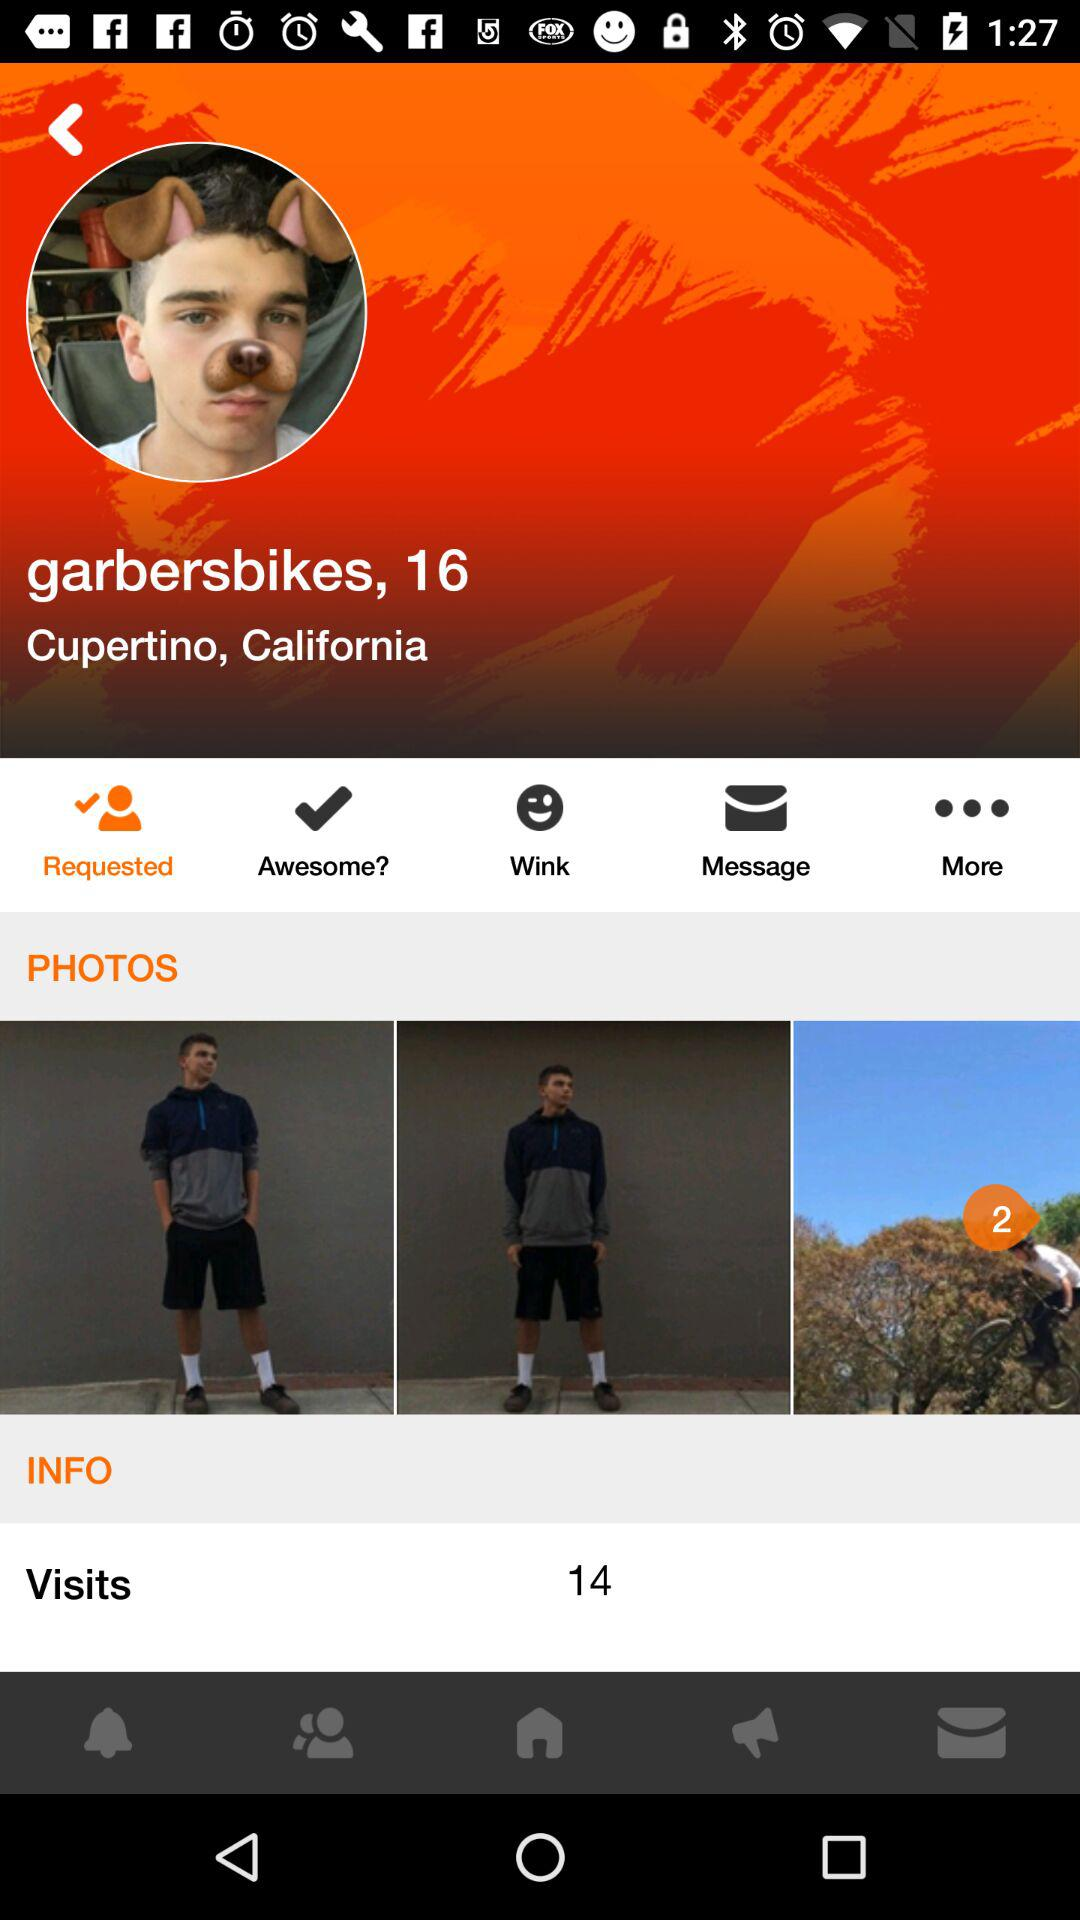What is the city name? The city name is Cupertino. 